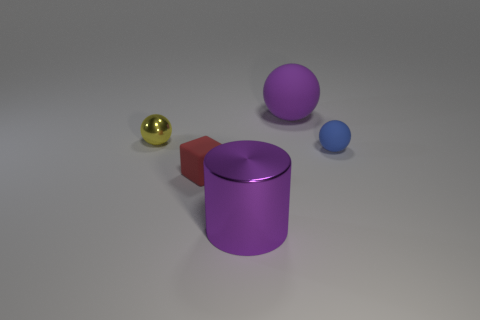What number of other objects are there of the same material as the yellow thing?
Offer a very short reply. 1. Is the number of tiny yellow metallic balls greater than the number of purple things?
Offer a very short reply. No. There is a small sphere that is to the left of the small red object that is right of the small thing that is behind the blue rubber object; what is it made of?
Ensure brevity in your answer.  Metal. Is the color of the shiny cylinder the same as the big sphere?
Your answer should be compact. Yes. Is there a metallic cylinder of the same color as the large matte object?
Your answer should be very brief. Yes. There is a red object that is the same size as the yellow metallic sphere; what shape is it?
Provide a succinct answer. Cube. Are there fewer purple rubber balls than tiny red cylinders?
Ensure brevity in your answer.  No. How many rubber spheres are the same size as the red cube?
Offer a very short reply. 1. What shape is the thing that is the same color as the big metallic cylinder?
Make the answer very short. Sphere. What is the material of the small blue sphere?
Offer a terse response. Rubber. 